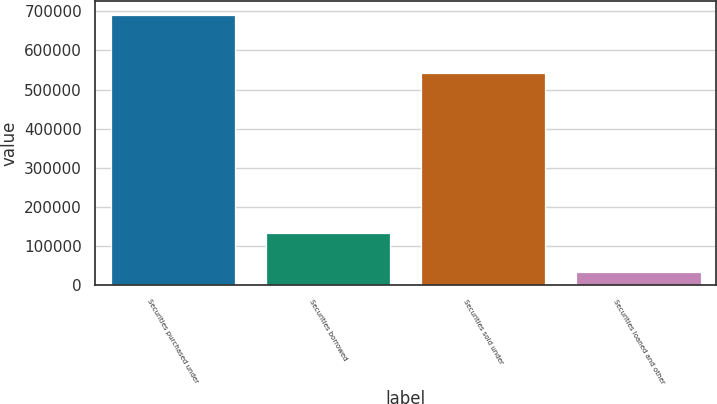Convert chart to OTSL. <chart><loc_0><loc_0><loc_500><loc_500><bar_chart><fcel>Securities purchased under<fcel>Securities borrowed<fcel>Securities sold under<fcel>Securities loaned and other<nl><fcel>691116<fcel>132955<fcel>541587<fcel>33700<nl></chart> 